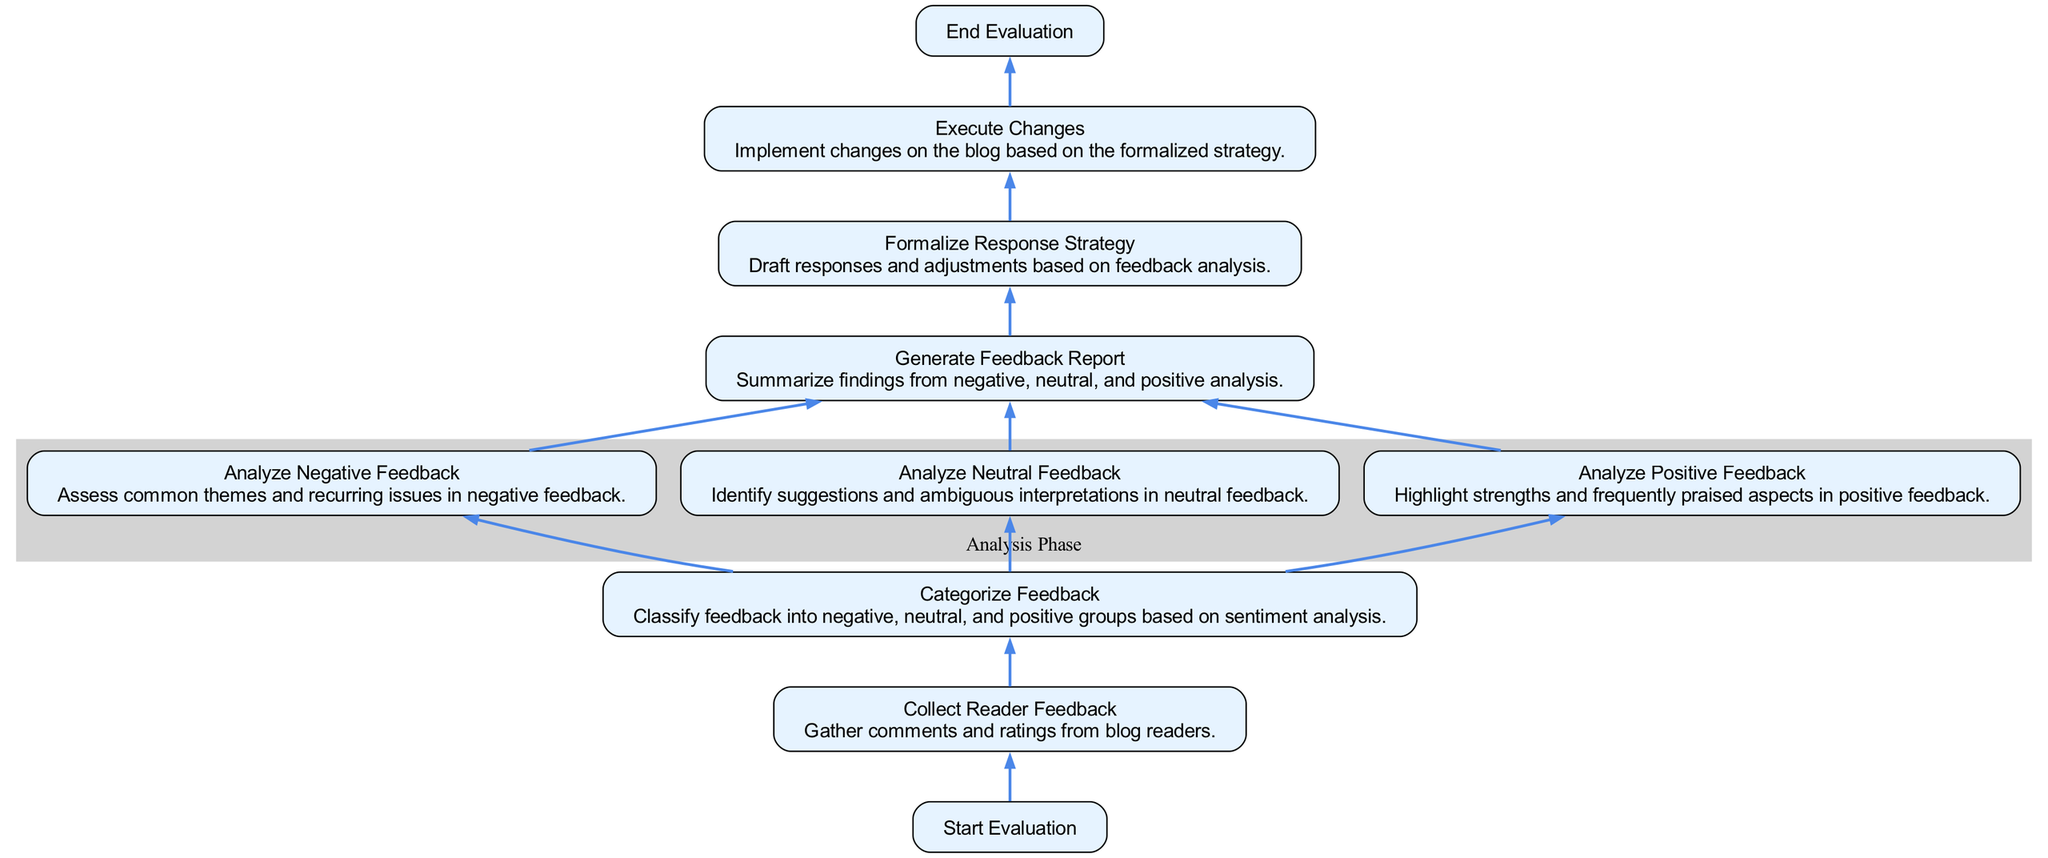What is the first step in the evaluation process? The first step, indicated at the bottom of the flowchart, is "Start Evaluation," which initiates the feedback evaluation process.
Answer: Start Evaluation How many categories of feedback analysis are there? In the diagram, feedback is categorized into three distinct groups: negative, neutral, and positive.
Answer: Three Which feedback type is analyzed after negative? After analyzing negative feedback, the next analysis focuses on neutral feedback as indicated in the flow from the categorization node.
Answer: Neutral Feedback What emerges from the analysis nodes? The analysis nodes "Analyze Negative," "Analyze Neutral," and "Analyze Positive" collectively produce findings that are summarized in the "Generate Feedback Report."
Answer: Feedback Report What is the end action after executing changes? After executing changes based on the response strategy, the flowchart indicates that the evaluation process concludes with the node labeled "End Evaluation."
Answer: End Evaluation What node follows the "Generate Feedback Report"? The node that follows "Generate Feedback Report" is "Formalize Response Strategy," which indicates that responses will be drafted based on the summarized findings.
Answer: Formalize Response Strategy Which color describes the Analysis Phase in the flowchart? The Analysis Phase is represented within a light grey cluster in the diagram, visually distinguishing it from other steps in the process.
Answer: Light Grey Which feedback type is highlighted for strengths? In the flowchart, it is explicitly stated that "Analyze Positive Feedback" highlights strengths and frequently praised aspects of the feedback received.
Answer: Positive Feedback What is the purpose of the "Collect Reader Feedback" node? The purpose of this node is to gather comments and ratings from blog readers, which serves as the initial input for the evaluation process.
Answer: Gather Comments and Ratings 